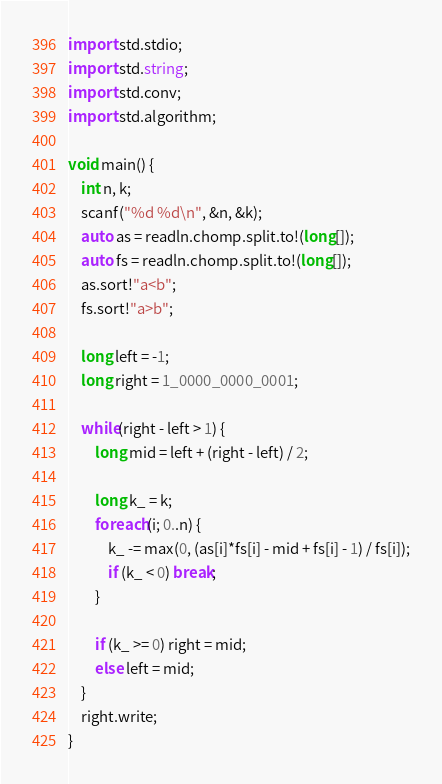Convert code to text. <code><loc_0><loc_0><loc_500><loc_500><_D_>import std.stdio;
import std.string;
import std.conv;
import std.algorithm;

void main() {
	int n, k;
	scanf("%d %d\n", &n, &k);
	auto as = readln.chomp.split.to!(long[]);
	auto fs = readln.chomp.split.to!(long[]);
	as.sort!"a<b";
	fs.sort!"a>b";

	long left = -1;
	long right = 1_0000_0000_0001;

	while(right - left > 1) {
		long mid = left + (right - left) / 2;

		long k_ = k;
		foreach(i; 0..n) {
			k_ -= max(0, (as[i]*fs[i] - mid + fs[i] - 1) / fs[i]);
			if (k_ < 0) break;
		}

		if (k_ >= 0) right = mid;
		else left = mid;
	}
	right.write;
}
</code> 